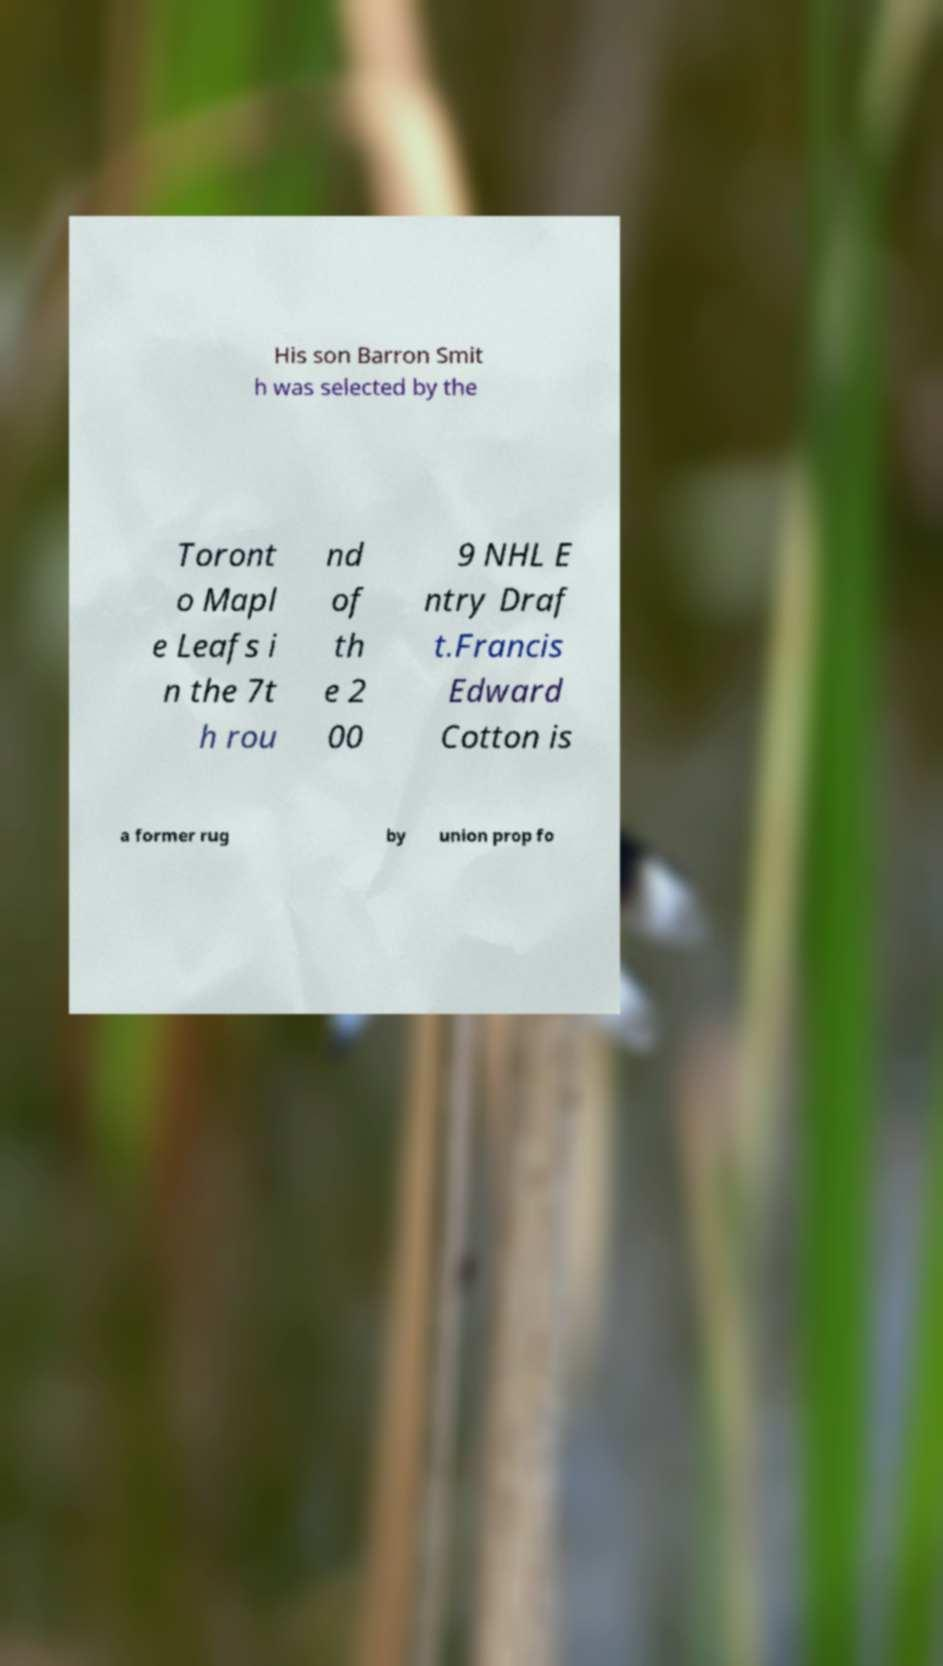Can you accurately transcribe the text from the provided image for me? His son Barron Smit h was selected by the Toront o Mapl e Leafs i n the 7t h rou nd of th e 2 00 9 NHL E ntry Draf t.Francis Edward Cotton is a former rug by union prop fo 